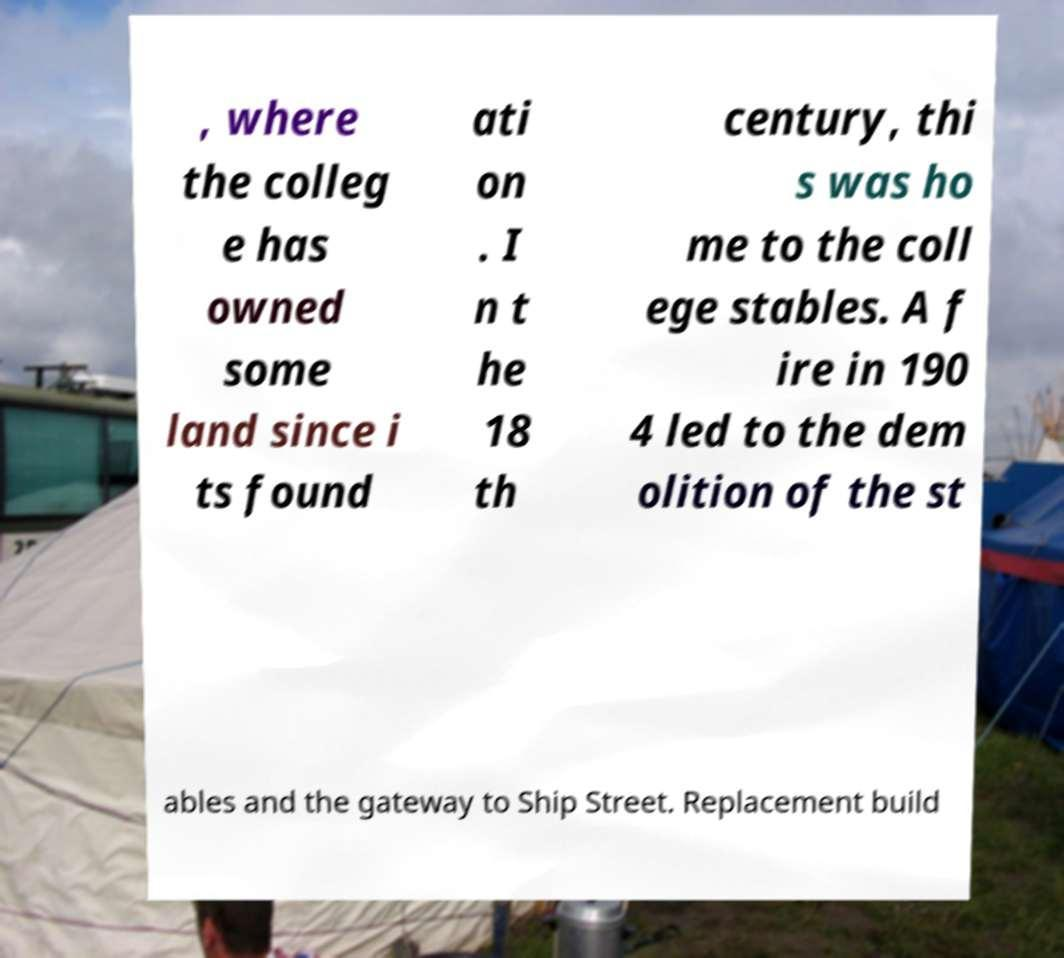There's text embedded in this image that I need extracted. Can you transcribe it verbatim? , where the colleg e has owned some land since i ts found ati on . I n t he 18 th century, thi s was ho me to the coll ege stables. A f ire in 190 4 led to the dem olition of the st ables and the gateway to Ship Street. Replacement build 